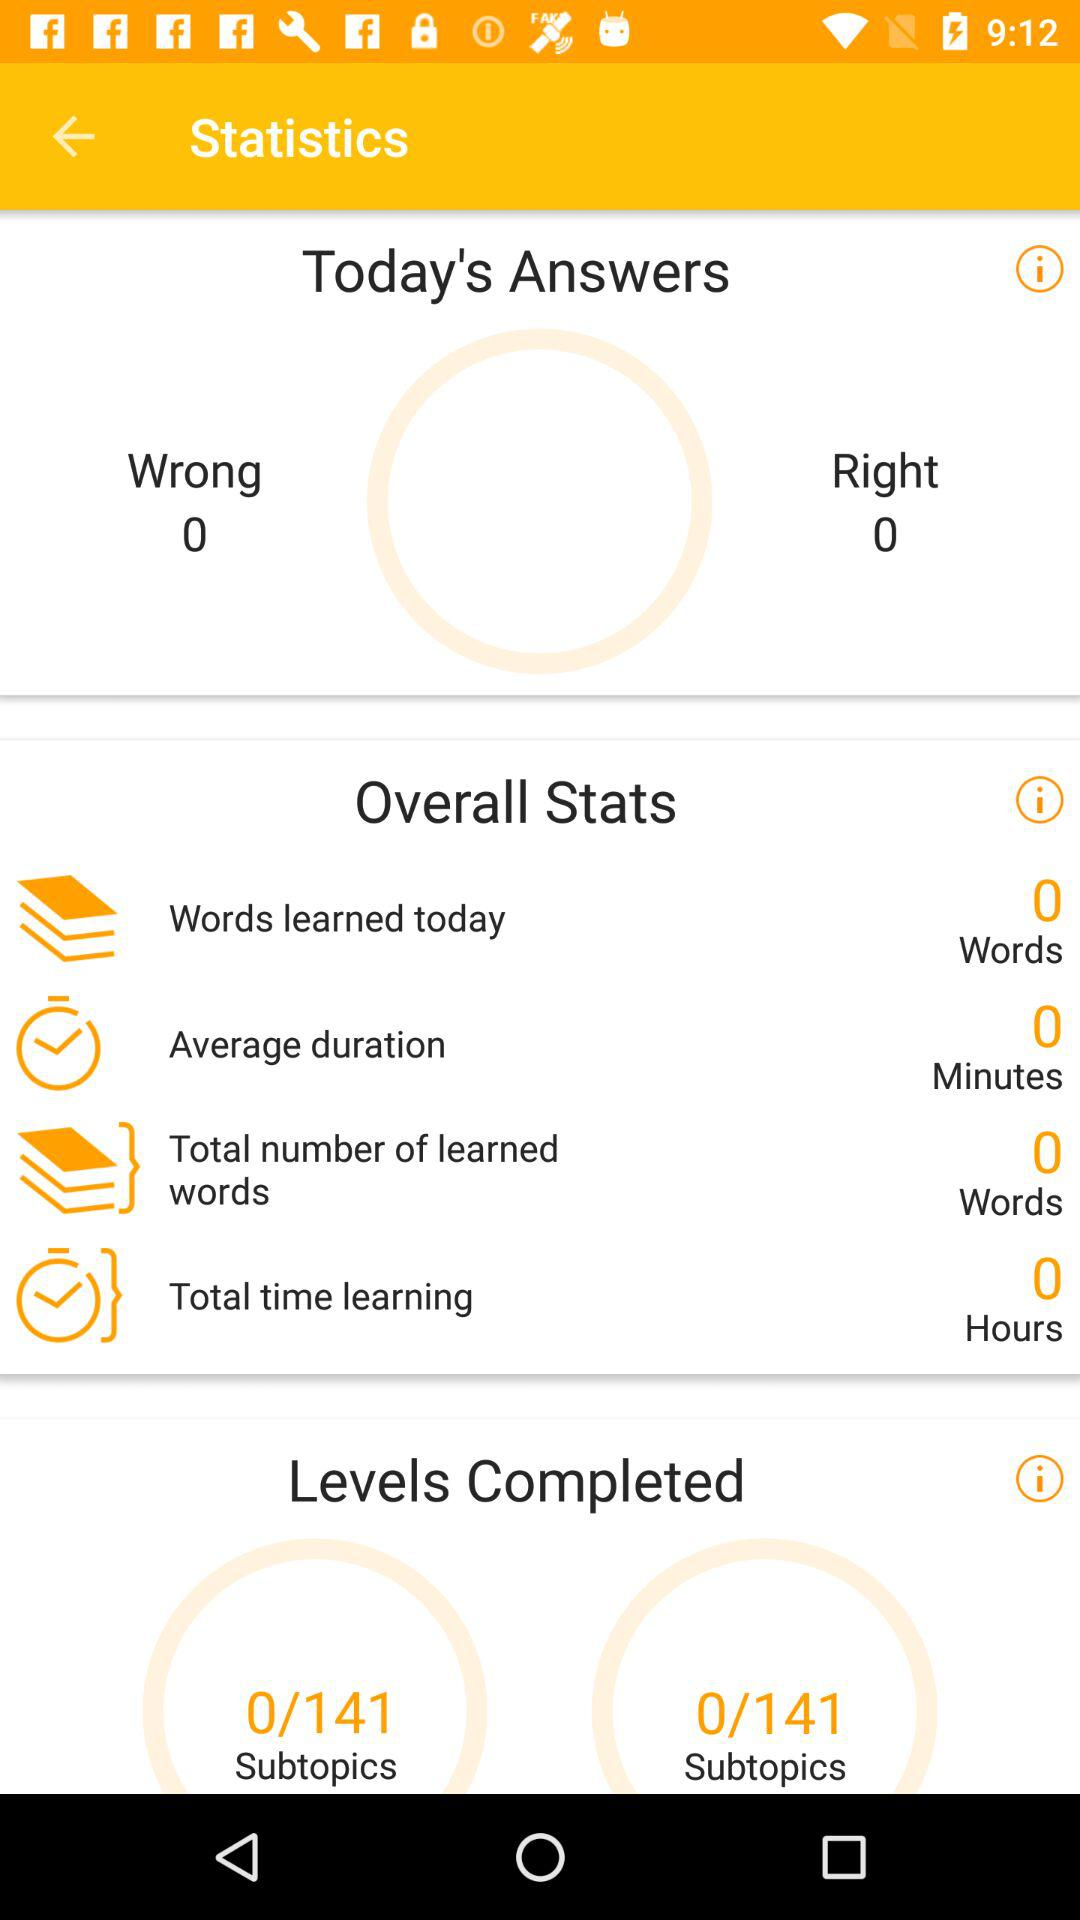How many wrong answers are there today? There are 0 wrong answers. 